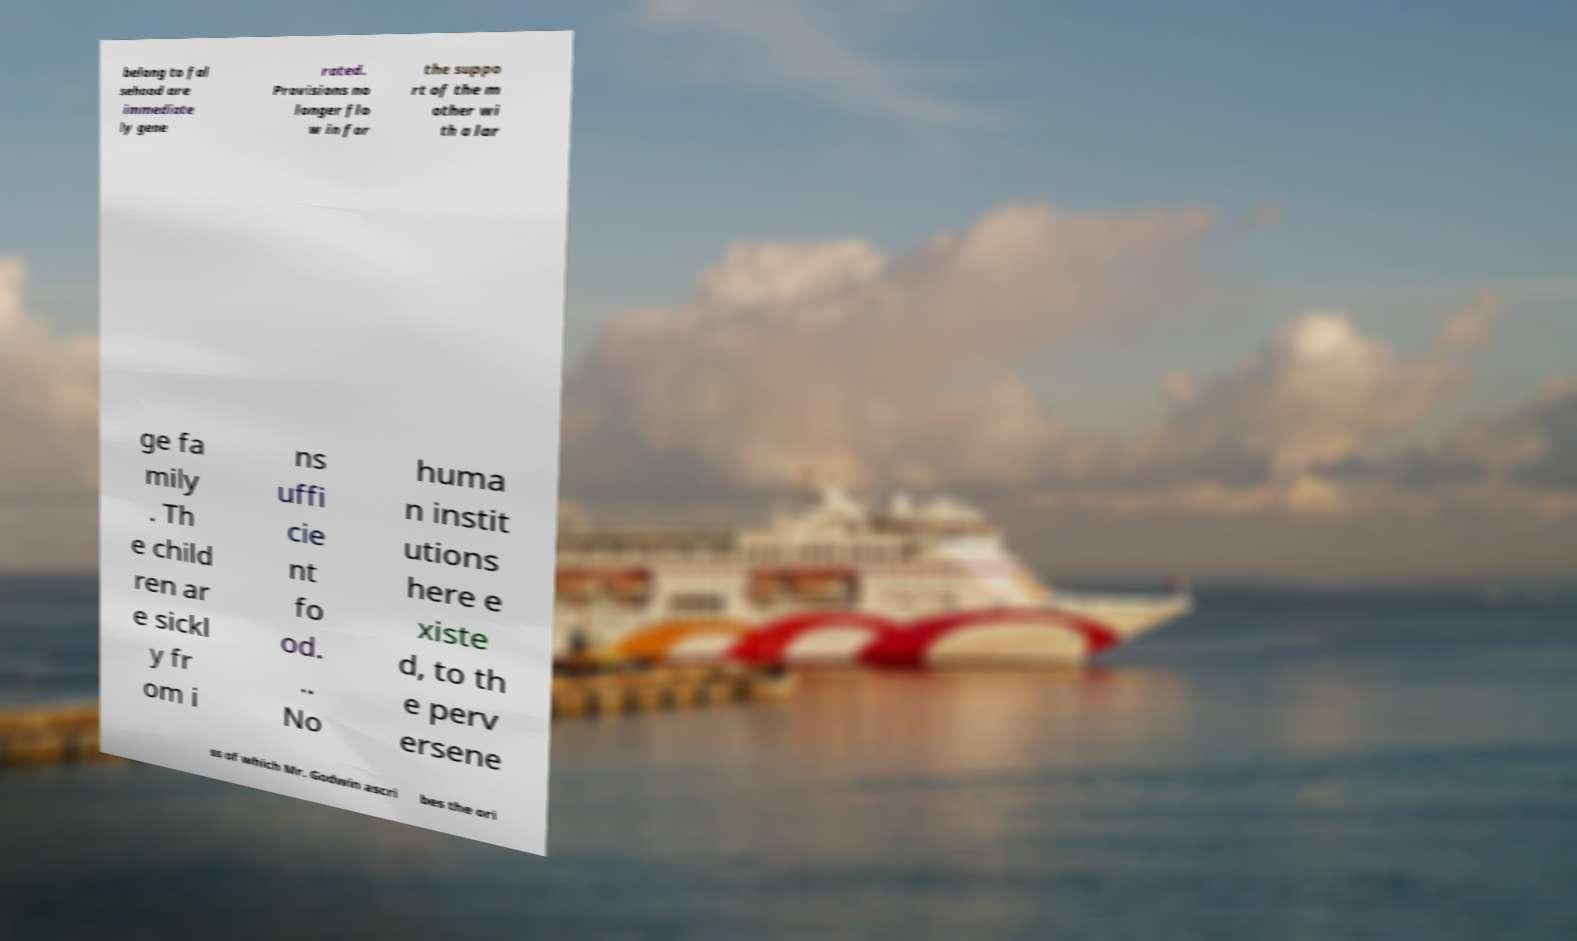There's text embedded in this image that I need extracted. Can you transcribe it verbatim? belong to fal sehood are immediate ly gene rated. Provisions no longer flo w in for the suppo rt of the m other wi th a lar ge fa mily . Th e child ren ar e sickl y fr om i ns uffi cie nt fo od. .. No huma n instit utions here e xiste d, to th e perv ersene ss of which Mr. Godwin ascri bes the ori 